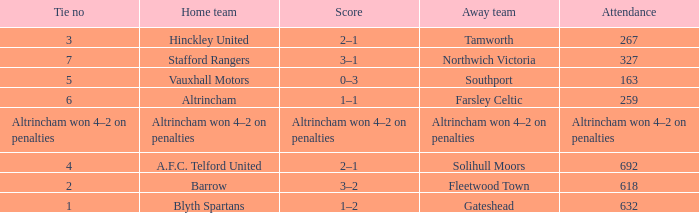Which home team had the away team Southport? Vauxhall Motors. 